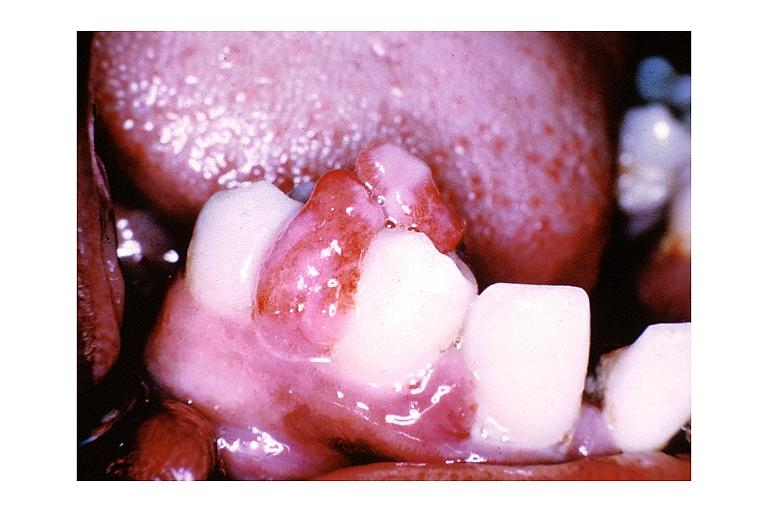what is present?
Answer the question using a single word or phrase. Oral 